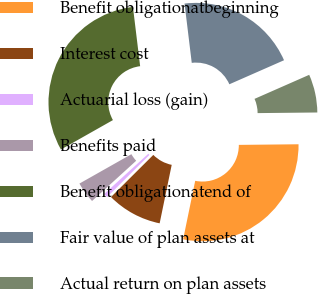<chart> <loc_0><loc_0><loc_500><loc_500><pie_chart><fcel>Benefit obligationatbeginning<fcel>Interest cost<fcel>Actuarial loss (gain)<fcel>Benefits paid<fcel>Benefit obligationatend of<fcel>Fair value of plan assets at<fcel>Actual return on plan assets<nl><fcel>28.4%<fcel>9.3%<fcel>0.7%<fcel>3.57%<fcel>31.27%<fcel>20.33%<fcel>6.43%<nl></chart> 